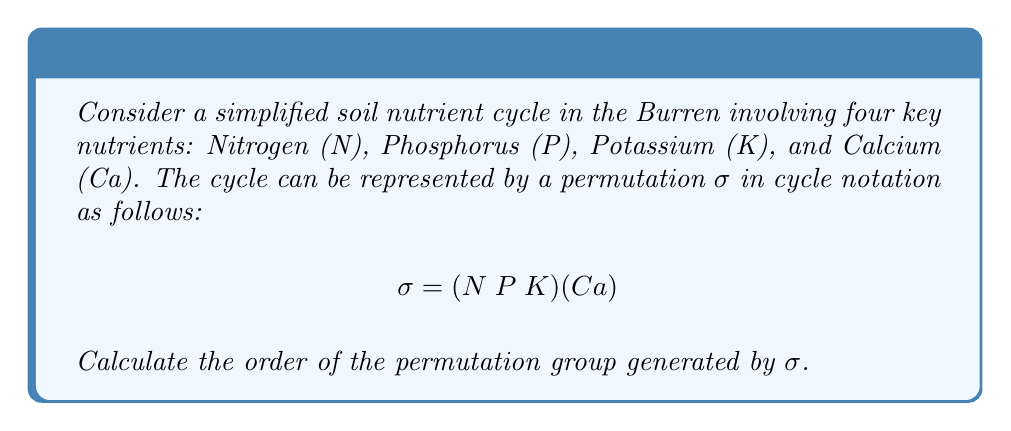Teach me how to tackle this problem. To find the order of the permutation group generated by $\sigma$, we need to determine the least common multiple (LCM) of the lengths of its disjoint cycles.

1. First, let's identify the cycle structure of $\sigma$:
   - $(N \; P \; K)$ is a 3-cycle
   - $(Ca)$ is a 1-cycle (fixed point)

2. The lengths of these cycles are 3 and 1, respectively.

3. The order of the permutation $\sigma$ is the LCM of these cycle lengths:
   $\text{order}(\sigma) = \text{LCM}(3, 1) = 3$

4. This means that $\sigma^3 = e$ (the identity permutation), and the group generated by $\sigma$ is:
   $\{\sigma^0 = e, \sigma^1, \sigma^2\}$

5. Therefore, the order of the permutation group generated by $\sigma$ is 3.

In the context of soil nutrient cycles, this result suggests that the simplified cycle represented by $\sigma$ will return to its initial state after three iterations, which could correspond to growing seasons or nutrient application cycles in the Burren's organic farming practices.
Answer: The order of the permutation group generated by $\sigma$ is 3. 